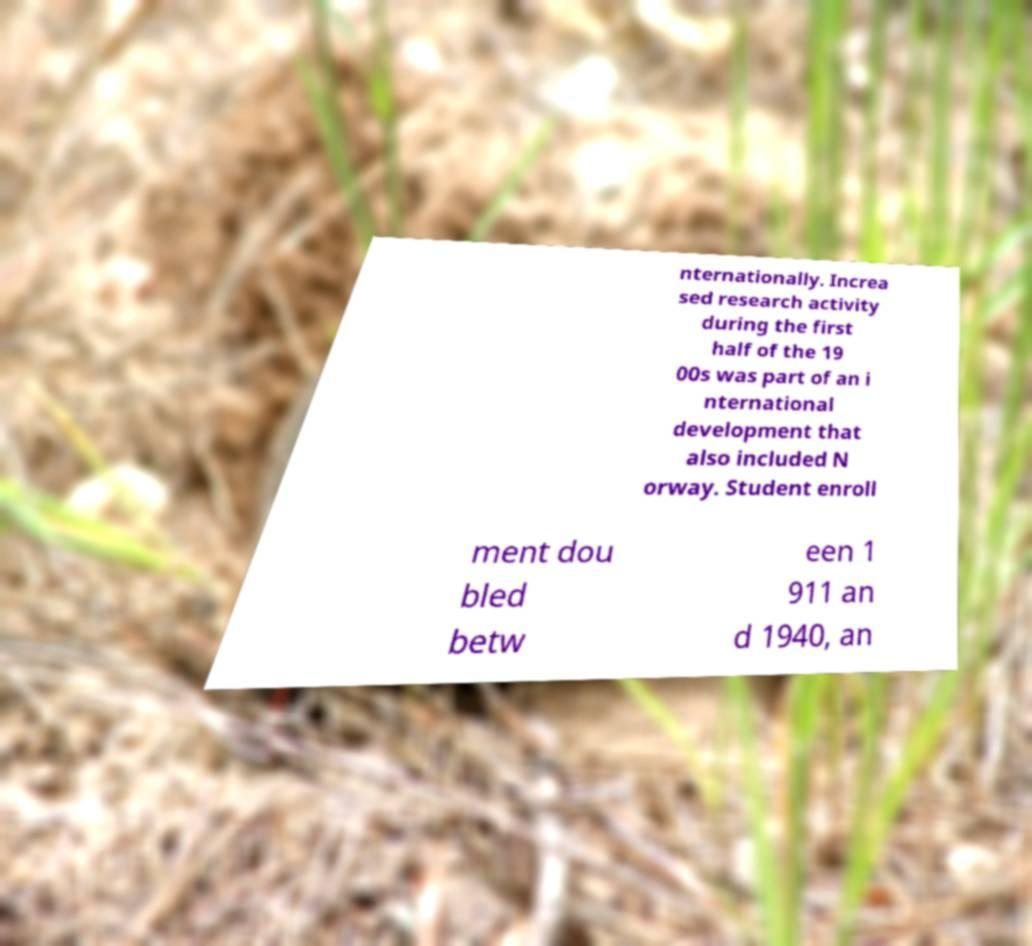Could you extract and type out the text from this image? nternationally. Increa sed research activity during the first half of the 19 00s was part of an i nternational development that also included N orway. Student enroll ment dou bled betw een 1 911 an d 1940, an 